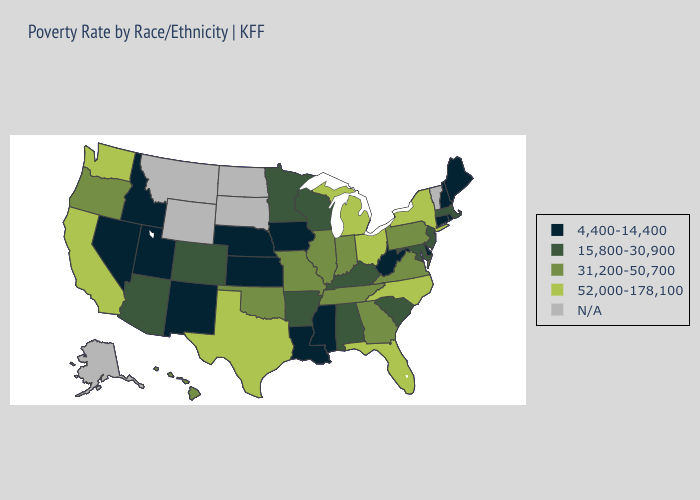What is the highest value in the USA?
Give a very brief answer. 52,000-178,100. Does New York have the lowest value in the USA?
Answer briefly. No. What is the highest value in states that border New York?
Keep it brief. 31,200-50,700. Does North Carolina have the lowest value in the USA?
Be succinct. No. Name the states that have a value in the range 15,800-30,900?
Answer briefly. Alabama, Arizona, Arkansas, Colorado, Kentucky, Maryland, Massachusetts, Minnesota, New Jersey, South Carolina, Wisconsin. Name the states that have a value in the range N/A?
Give a very brief answer. Alaska, Montana, North Dakota, South Dakota, Vermont, Wyoming. Name the states that have a value in the range 31,200-50,700?
Keep it brief. Georgia, Hawaii, Illinois, Indiana, Missouri, Oklahoma, Oregon, Pennsylvania, Tennessee, Virginia. Name the states that have a value in the range 4,400-14,400?
Answer briefly. Connecticut, Delaware, Idaho, Iowa, Kansas, Louisiana, Maine, Mississippi, Nebraska, Nevada, New Hampshire, New Mexico, Rhode Island, Utah, West Virginia. Does New Mexico have the lowest value in the USA?
Answer briefly. Yes. Name the states that have a value in the range 31,200-50,700?
Concise answer only. Georgia, Hawaii, Illinois, Indiana, Missouri, Oklahoma, Oregon, Pennsylvania, Tennessee, Virginia. Does Indiana have the lowest value in the MidWest?
Be succinct. No. Among the states that border Oklahoma , does Arkansas have the lowest value?
Keep it brief. No. Among the states that border Wisconsin , does Minnesota have the lowest value?
Write a very short answer. No. 